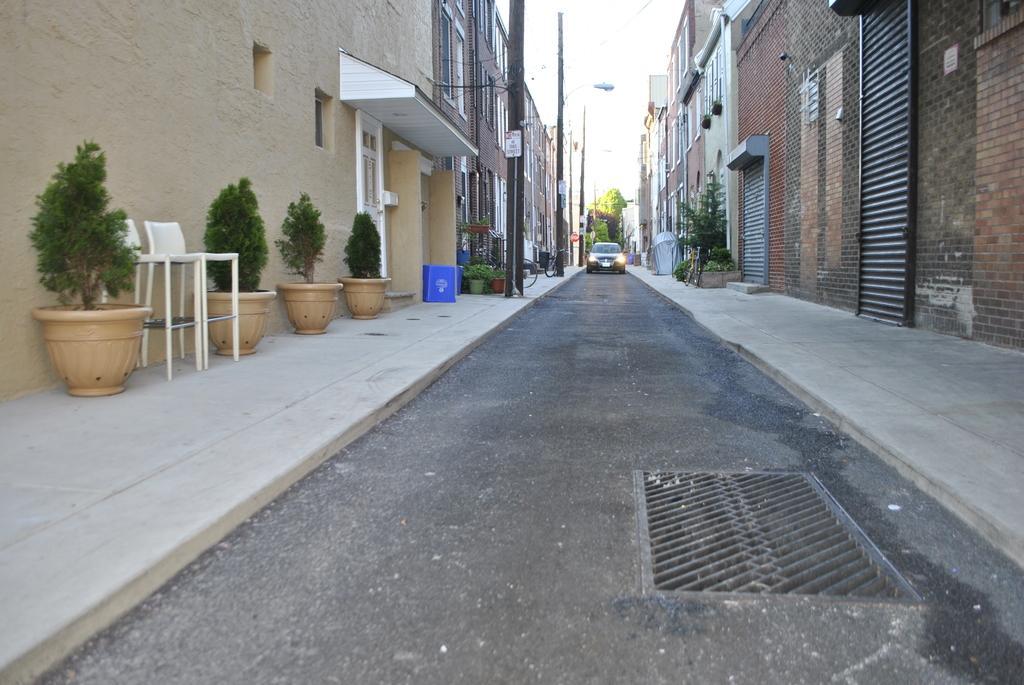In one or two sentences, can you explain what this image depicts? In this image I can see road and on it I can see a vehicle. I can also see number of buildings, poles, few chairs and number of plants in pots. 